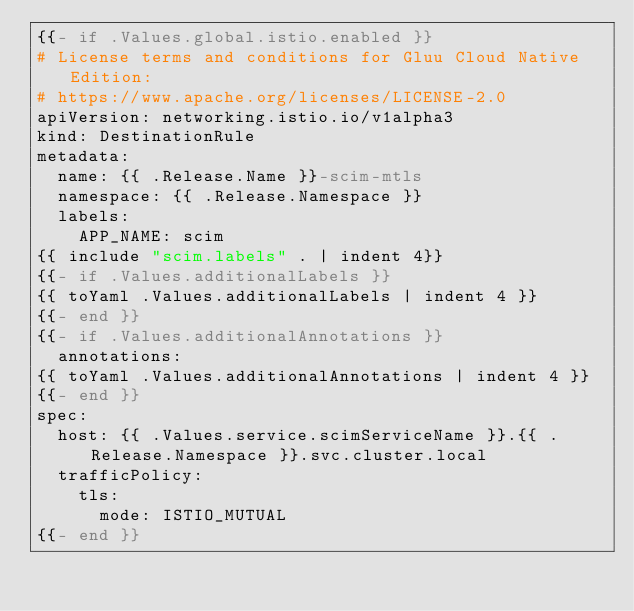Convert code to text. <code><loc_0><loc_0><loc_500><loc_500><_YAML_>{{- if .Values.global.istio.enabled }}
# License terms and conditions for Gluu Cloud Native Edition:
# https://www.apache.org/licenses/LICENSE-2.0
apiVersion: networking.istio.io/v1alpha3
kind: DestinationRule
metadata:
  name: {{ .Release.Name }}-scim-mtls
  namespace: {{ .Release.Namespace }}
  labels:
    APP_NAME: scim
{{ include "scim.labels" . | indent 4}}
{{- if .Values.additionalLabels }}
{{ toYaml .Values.additionalLabels | indent 4 }}
{{- end }}
{{- if .Values.additionalAnnotations }}
  annotations:
{{ toYaml .Values.additionalAnnotations | indent 4 }}
{{- end }}
spec:
  host: {{ .Values.service.scimServiceName }}.{{ .Release.Namespace }}.svc.cluster.local
  trafficPolicy:
    tls:
      mode: ISTIO_MUTUAL
{{- end }}</code> 